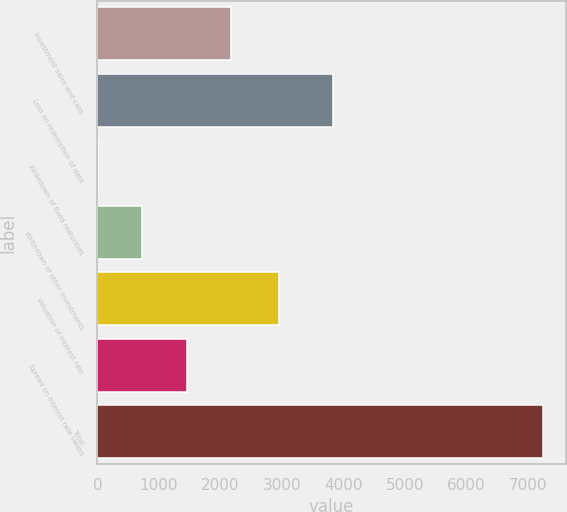<chart> <loc_0><loc_0><loc_500><loc_500><bar_chart><fcel>Investment sales and calls<fcel>Loss on redemption of debt<fcel>Writedown of fixed maturities<fcel>Writedown of other investments<fcel>Valuation of interest rate<fcel>Spread on interest rate swaps<fcel>Total<nl><fcel>2178.82<fcel>3830<fcel>3.76<fcel>728.78<fcel>2956<fcel>1453.8<fcel>7254<nl></chart> 